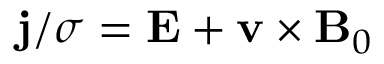<formula> <loc_0><loc_0><loc_500><loc_500>j / \sigma = E + v \times B _ { 0 }</formula> 